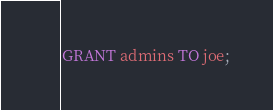<code> <loc_0><loc_0><loc_500><loc_500><_SQL_>GRANT admins TO joe;
</code> 